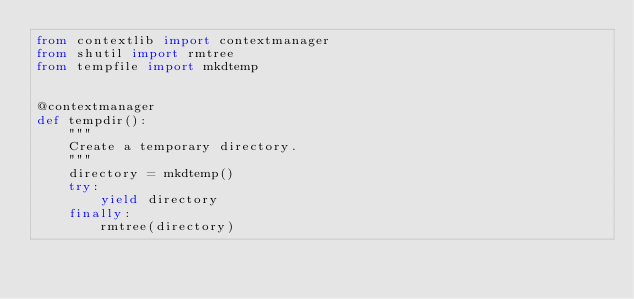<code> <loc_0><loc_0><loc_500><loc_500><_Python_>from contextlib import contextmanager
from shutil import rmtree
from tempfile import mkdtemp


@contextmanager
def tempdir():
    """
    Create a temporary directory.
    """
    directory = mkdtemp()
    try:
        yield directory
    finally:
        rmtree(directory)
</code> 